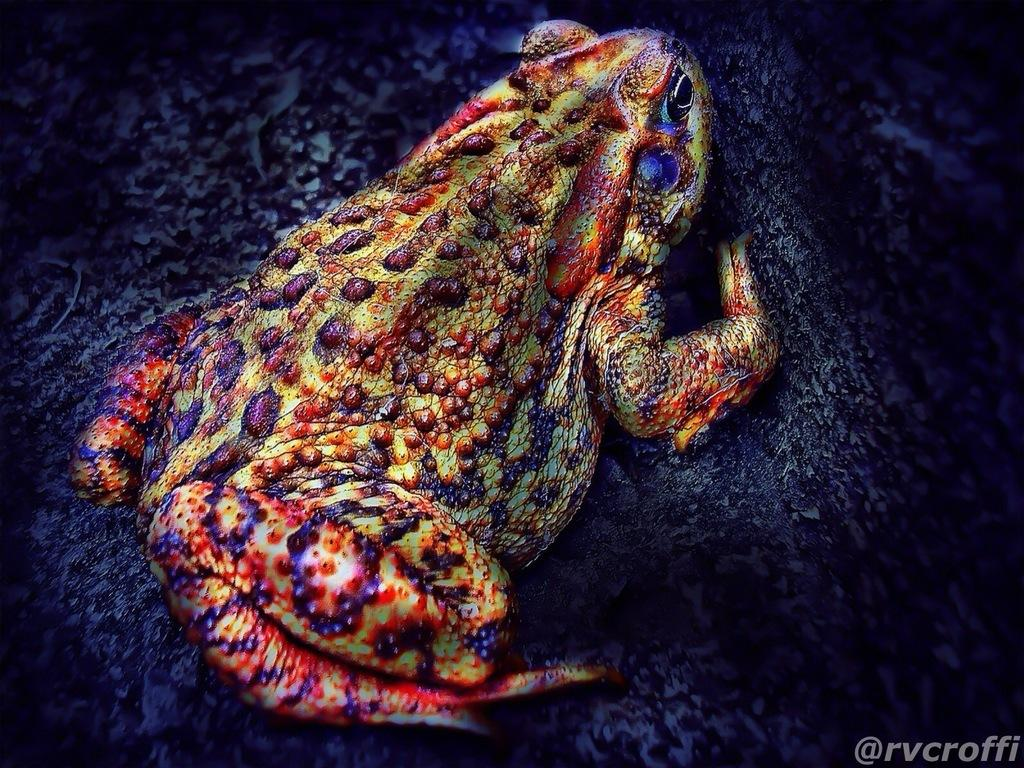What animal can be seen in the picture? There is a frog in the picture. What colors are present on the frog? The frog is yellow and purple in color. What is the frog sitting on? The frog is sitting on a rock. Is there any text or marking at the bottom of the image? Yes, there is a small watermark at the bottom of the image. What type of soup is being served in the image? There is no soup present in the image; it features a yellow and purple frog sitting on a rock. Is the frog wearing a boot in the image? No, the frog is not wearing a boot in the image; it is simply sitting on a rock. 